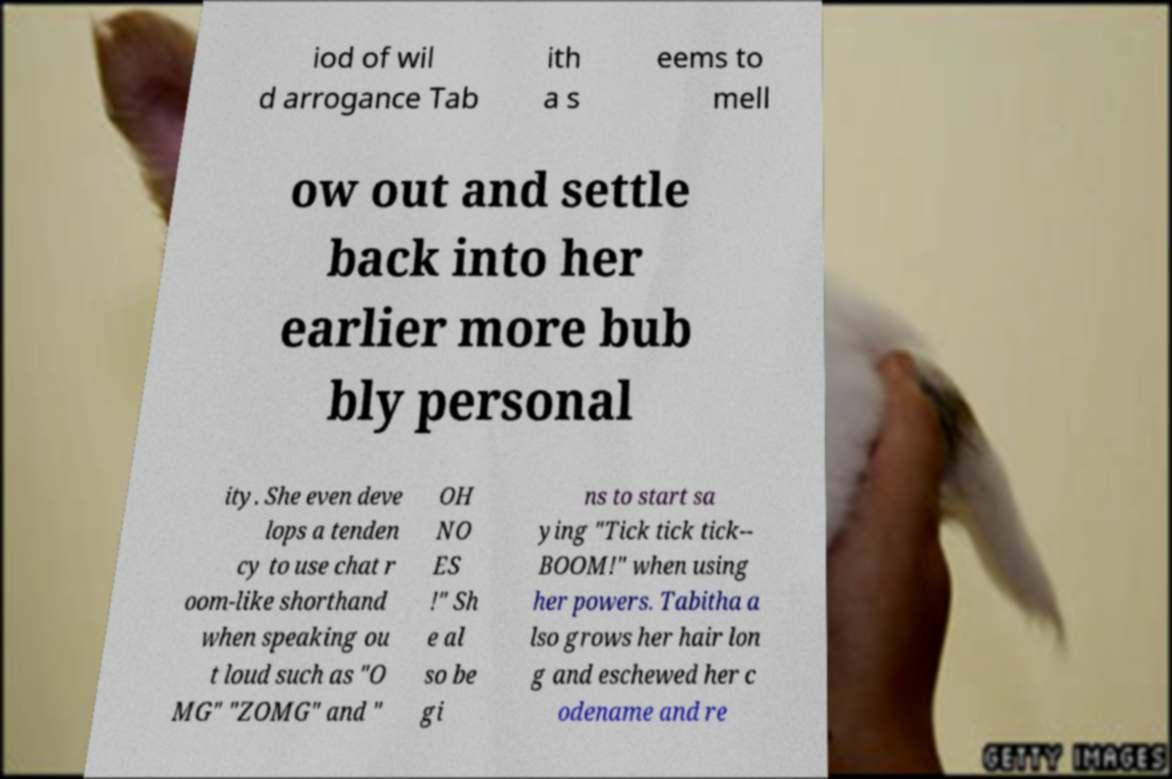I need the written content from this picture converted into text. Can you do that? iod of wil d arrogance Tab ith a s eems to mell ow out and settle back into her earlier more bub bly personal ity. She even deve lops a tenden cy to use chat r oom-like shorthand when speaking ou t loud such as "O MG" "ZOMG" and " OH NO ES !" Sh e al so be gi ns to start sa ying "Tick tick tick-- BOOM!" when using her powers. Tabitha a lso grows her hair lon g and eschewed her c odename and re 